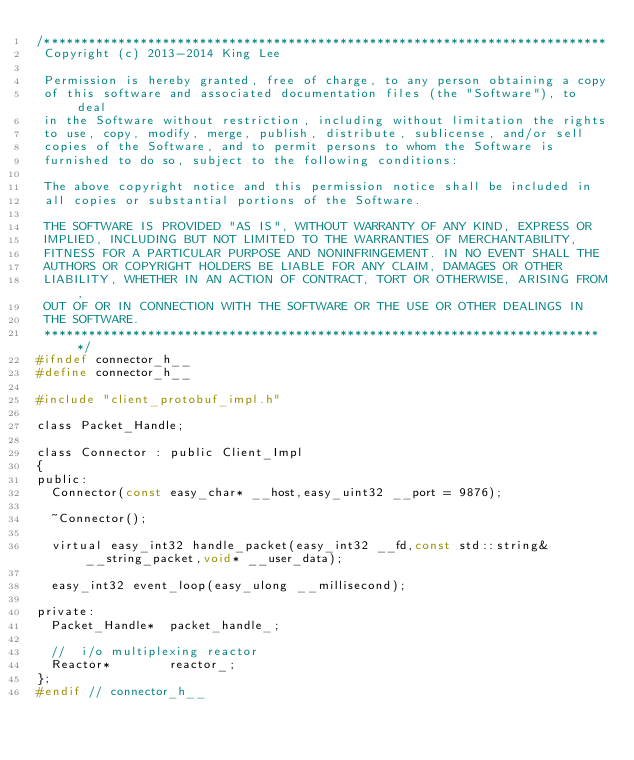Convert code to text. <code><loc_0><loc_0><loc_500><loc_500><_C_>/****************************************************************************
 Copyright (c) 2013-2014 King Lee

 Permission is hereby granted, free of charge, to any person obtaining a copy
 of this software and associated documentation files (the "Software"), to deal
 in the Software without restriction, including without limitation the rights
 to use, copy, modify, merge, publish, distribute, sublicense, and/or sell
 copies of the Software, and to permit persons to whom the Software is
 furnished to do so, subject to the following conditions:

 The above copyright notice and this permission notice shall be included in
 all copies or substantial portions of the Software.

 THE SOFTWARE IS PROVIDED "AS IS", WITHOUT WARRANTY OF ANY KIND, EXPRESS OR
 IMPLIED, INCLUDING BUT NOT LIMITED TO THE WARRANTIES OF MERCHANTABILITY,
 FITNESS FOR A PARTICULAR PURPOSE AND NONINFRINGEMENT. IN NO EVENT SHALL THE
 AUTHORS OR COPYRIGHT HOLDERS BE LIABLE FOR ANY CLAIM, DAMAGES OR OTHER
 LIABILITY, WHETHER IN AN ACTION OF CONTRACT, TORT OR OTHERWISE, ARISING FROM,
 OUT OF OR IN CONNECTION WITH THE SOFTWARE OR THE USE OR OTHER DEALINGS IN
 THE SOFTWARE.
 ****************************************************************************/
#ifndef connector_h__
#define connector_h__

#include "client_protobuf_impl.h"

class Packet_Handle;

class Connector : public Client_Impl
{
public:
	Connector(const easy_char* __host,easy_uint32 __port = 9876);

	~Connector();

	virtual easy_int32 handle_packet(easy_int32 __fd,const std::string& __string_packet,void* __user_data);

	easy_int32 event_loop(easy_ulong __millisecond);

private:
	Packet_Handle*  packet_handle_;

	//	i/o multiplexing reactor
	Reactor*				reactor_;
};
#endif // connector_h__
</code> 